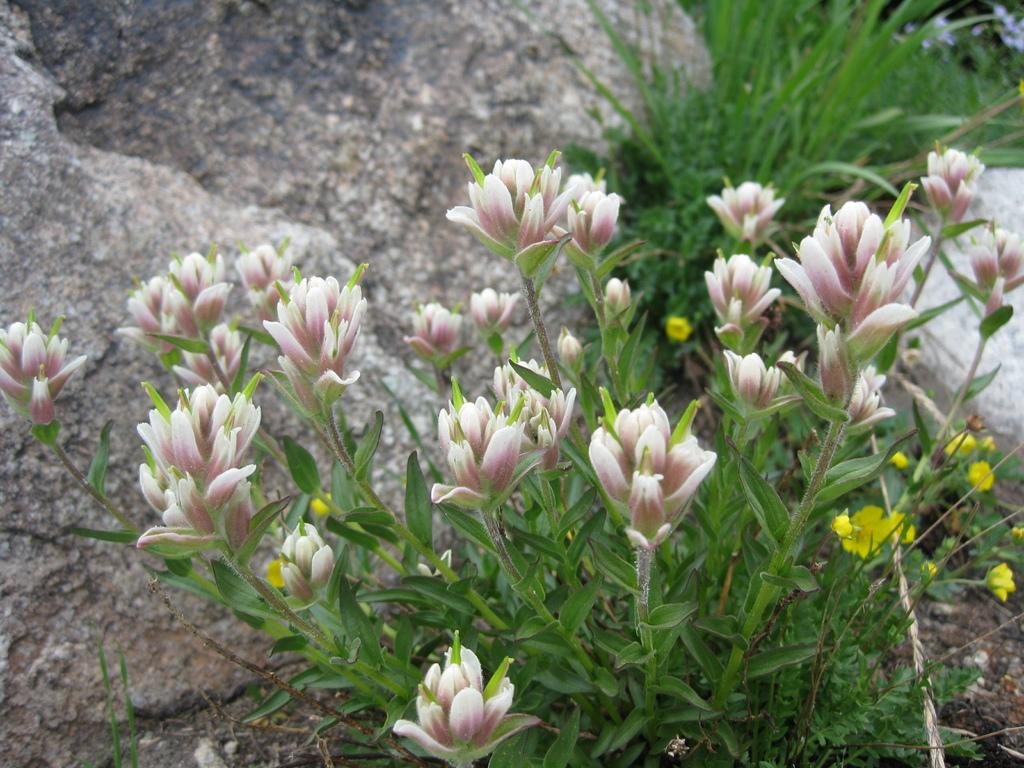What is located in the center of the image? There are flowers, plants, and stones in the center of the image. Can you describe the flowers in the image? Unfortunately, the facts provided do not give specific details about the flowers. What else is present in the center of the image besides flowers? There are plants and stones in the center of the image. What type of house is depicted in the image? There is no house present in the image; it features flowers, plants, and stones. What wish can be granted by touching the flowers in the image? There is no mention of wishes or magic in the image; it simply shows flowers, plants, and stones. 